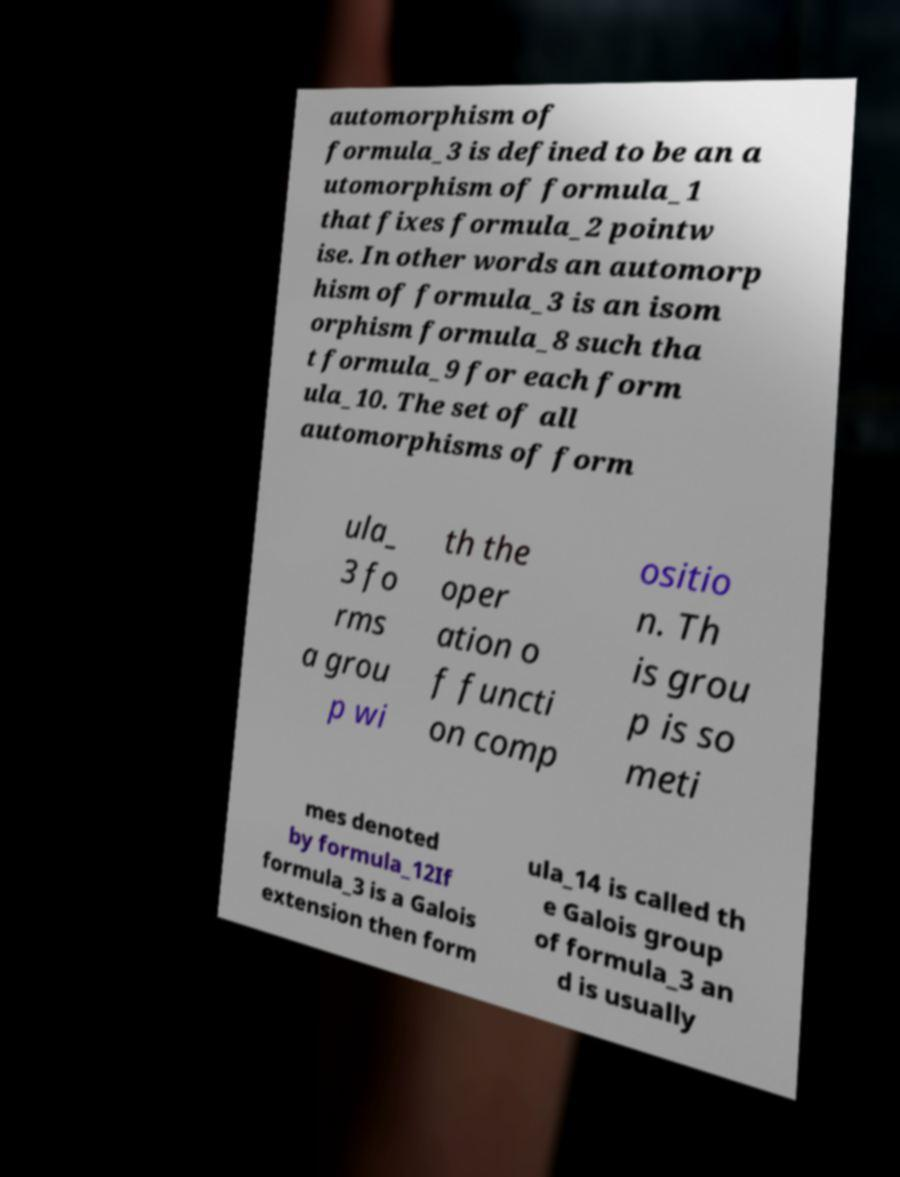For documentation purposes, I need the text within this image transcribed. Could you provide that? automorphism of formula_3 is defined to be an a utomorphism of formula_1 that fixes formula_2 pointw ise. In other words an automorp hism of formula_3 is an isom orphism formula_8 such tha t formula_9 for each form ula_10. The set of all automorphisms of form ula_ 3 fo rms a grou p wi th the oper ation o f functi on comp ositio n. Th is grou p is so meti mes denoted by formula_12If formula_3 is a Galois extension then form ula_14 is called th e Galois group of formula_3 an d is usually 